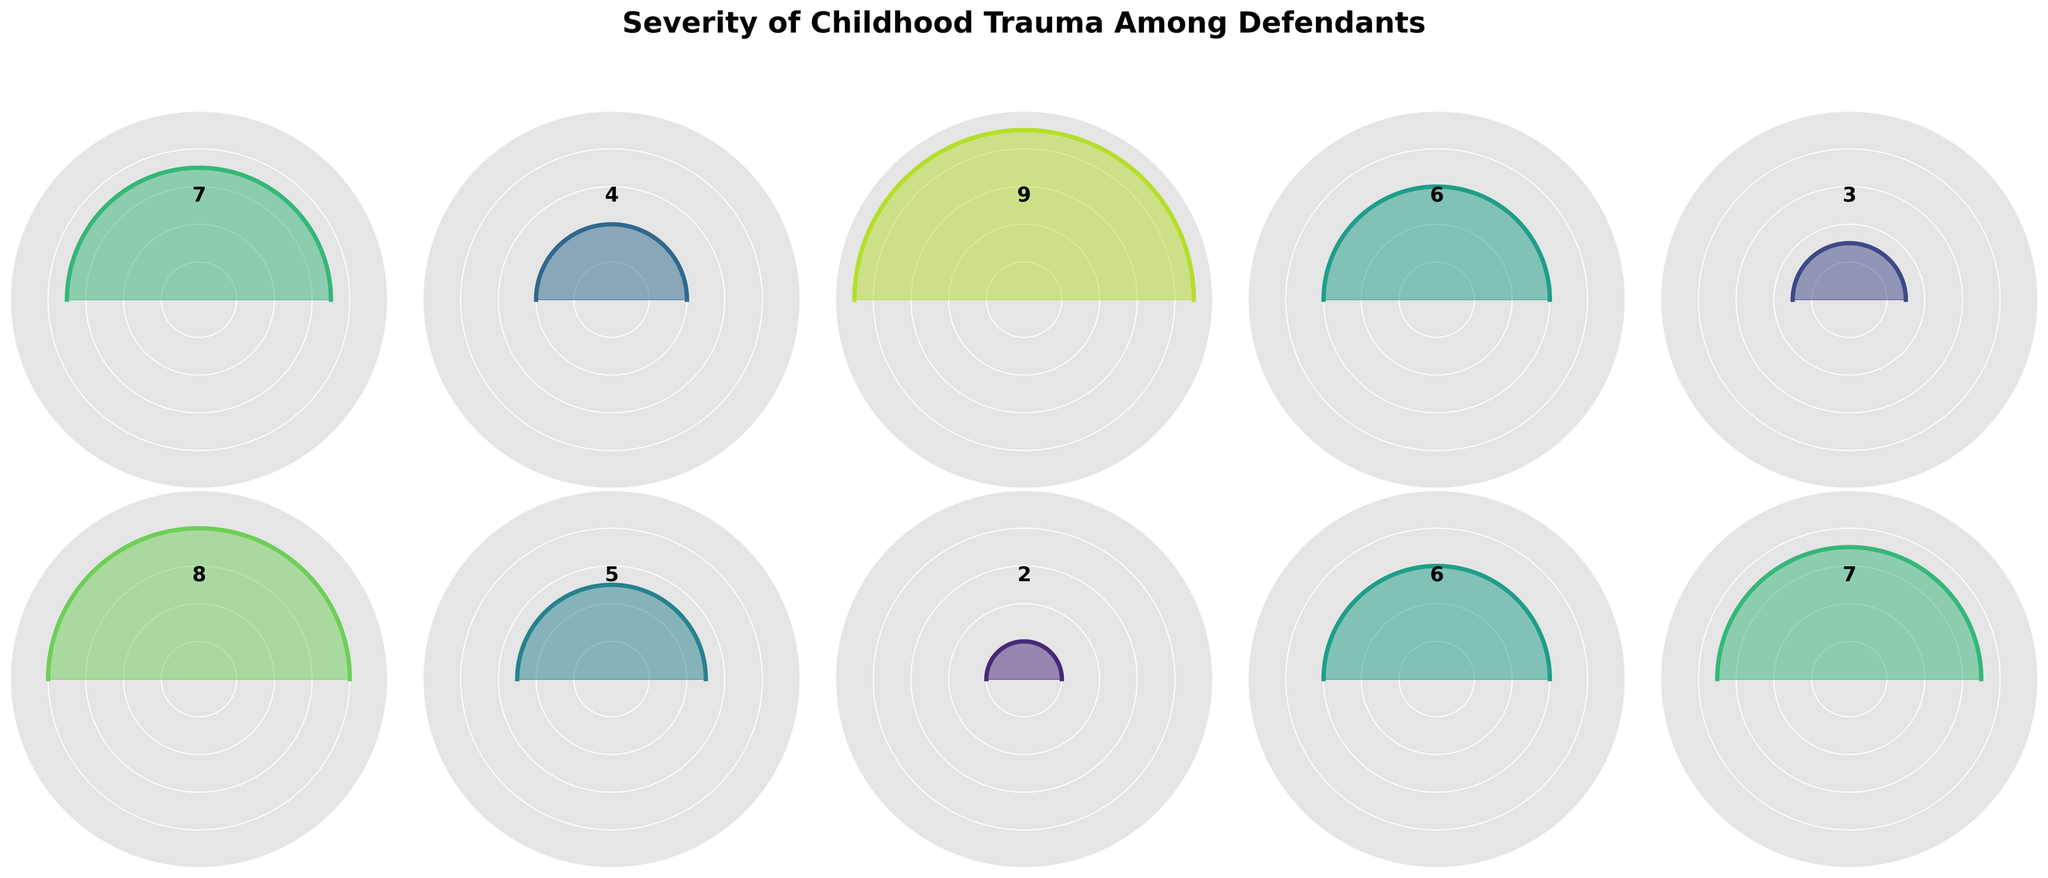What is the title of the figure? The title of the figure is typically given at the top. It reads "Severity of Childhood Trauma Among Defendants". This provides the context of what the figure is about.
Answer: Severity of Childhood Trauma Among Defendants What is the trauma severity level of Michael Smith? To find the trauma severity level for Michael Smith, locate his name and check the corresponding severity number beside it. The severity rating is associated with the name.
Answer: 9 Which defendant has the lowest trauma severity? To identify the defendant with the lowest trauma severity, find the gauge chart with the smallest filled gauge. The corresponding text will indicate the name.
Answer: Jennifer Lee How many defendants have a trauma severity of 6 or above? Count the number of gauge charts with severity values of 6 or higher, indicated by the number inside or next to the gauge. Sum the counts for each severity level of 6, 7, 8, and 9.
Answer: 6 What is the average trauma severity among all defendants? Add all the trauma severity values and divide by the number of defendants. The total severity is 7+4+9+6+3+8+5+2+6+7. Dividing this by 10 gives the average.
Answer: 5.7 Which two defendants have the exact same trauma severity level, and what is that level? Compare the trauma severity numbers across all gauges to identify identical values. Two gauges showing the same value will indicate a match.
Answer: Emily Brown and Christopher Taylor both have a severity level of 6 What is the difference in trauma severity between Amanda Martinez and Robert Wilson? Find Amanda Martinez and Robert Wilson's trauma severity levels and subtract Robert's severity from Amanda's. Amanda's severity is 7 and Robert's is 3. Subtracting 3 from 7 gives the difference.
Answer: 4 Who has a trauma severity level of 4? Look for the gauge chart with the number 4 indicated on it. The name associated with this gauge will be the answer.
Answer: Sarah Johnson Is there any defendant with a trauma severity of 10? Check all gauge charts to see if any of them reach the maximum severity level of 10. If none do, the answer is no.
Answer: No 